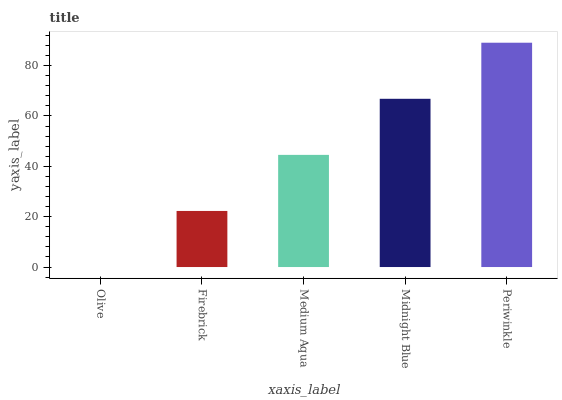Is Olive the minimum?
Answer yes or no. Yes. Is Periwinkle the maximum?
Answer yes or no. Yes. Is Firebrick the minimum?
Answer yes or no. No. Is Firebrick the maximum?
Answer yes or no. No. Is Firebrick greater than Olive?
Answer yes or no. Yes. Is Olive less than Firebrick?
Answer yes or no. Yes. Is Olive greater than Firebrick?
Answer yes or no. No. Is Firebrick less than Olive?
Answer yes or no. No. Is Medium Aqua the high median?
Answer yes or no. Yes. Is Medium Aqua the low median?
Answer yes or no. Yes. Is Firebrick the high median?
Answer yes or no. No. Is Firebrick the low median?
Answer yes or no. No. 